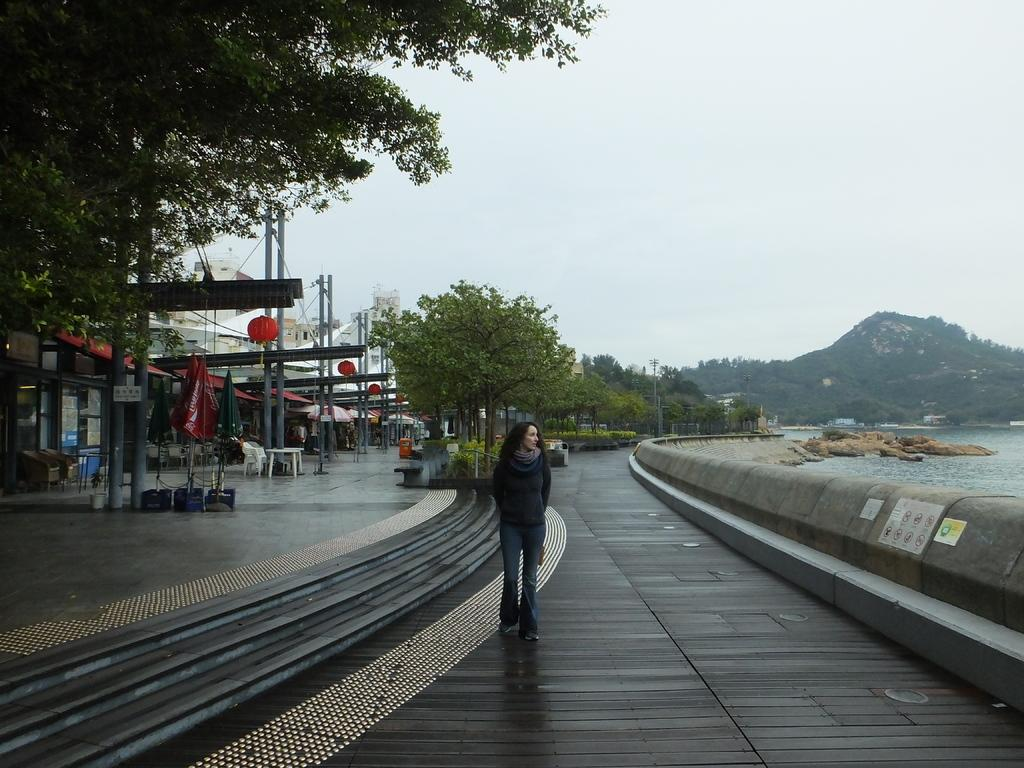What type of structures can be seen in the image? There are buildings in the image. What natural elements are present in the image? There are trees and water visible in the image. What type of terrain is depicted in the image? There are rocks in the image. What is the woman in the image doing? There is a woman walking in the image. What objects are present for shelter or shade? There are umbrellas in the image. What type of furniture is visible in the image? There are chairs and a table in the image. What type of art can be seen on the table in the image? There is no art present on the table in the image. How does the crowd affect the taste of the water in the image? There is no crowd present in the image, and the taste of the water is not affected by any crowd. 